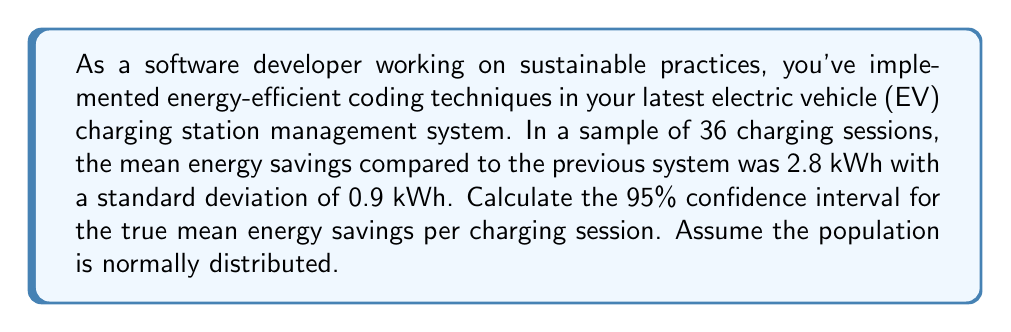Show me your answer to this math problem. To calculate the 95% confidence interval, we'll follow these steps:

1) The formula for the confidence interval is:

   $$ \bar{x} \pm t_{\alpha/2} \cdot \frac{s}{\sqrt{n}} $$

   Where:
   $\bar{x}$ is the sample mean
   $t_{\alpha/2}$ is the t-value for 95% confidence level
   $s$ is the sample standard deviation
   $n$ is the sample size

2) We know:
   $\bar{x} = 2.8$ kWh
   $s = 0.9$ kWh
   $n = 36$

3) For a 95% confidence interval with 35 degrees of freedom (n-1), the t-value is approximately 2.030 (from t-distribution table).

4) Plugging into the formula:

   $$ 2.8 \pm 2.030 \cdot \frac{0.9}{\sqrt{36}} $$

5) Simplify:
   $$ 2.8 \pm 2.030 \cdot \frac{0.9}{6} $$
   $$ 2.8 \pm 2.030 \cdot 0.15 $$
   $$ 2.8 \pm 0.3045 $$

6) Calculate the interval:
   Lower bound: $2.8 - 0.3045 = 2.4955$
   Upper bound: $2.8 + 0.3045 = 3.1045$

Therefore, the 95% confidence interval is (2.4955, 3.1045) kWh.
Answer: (2.50, 3.10) kWh 